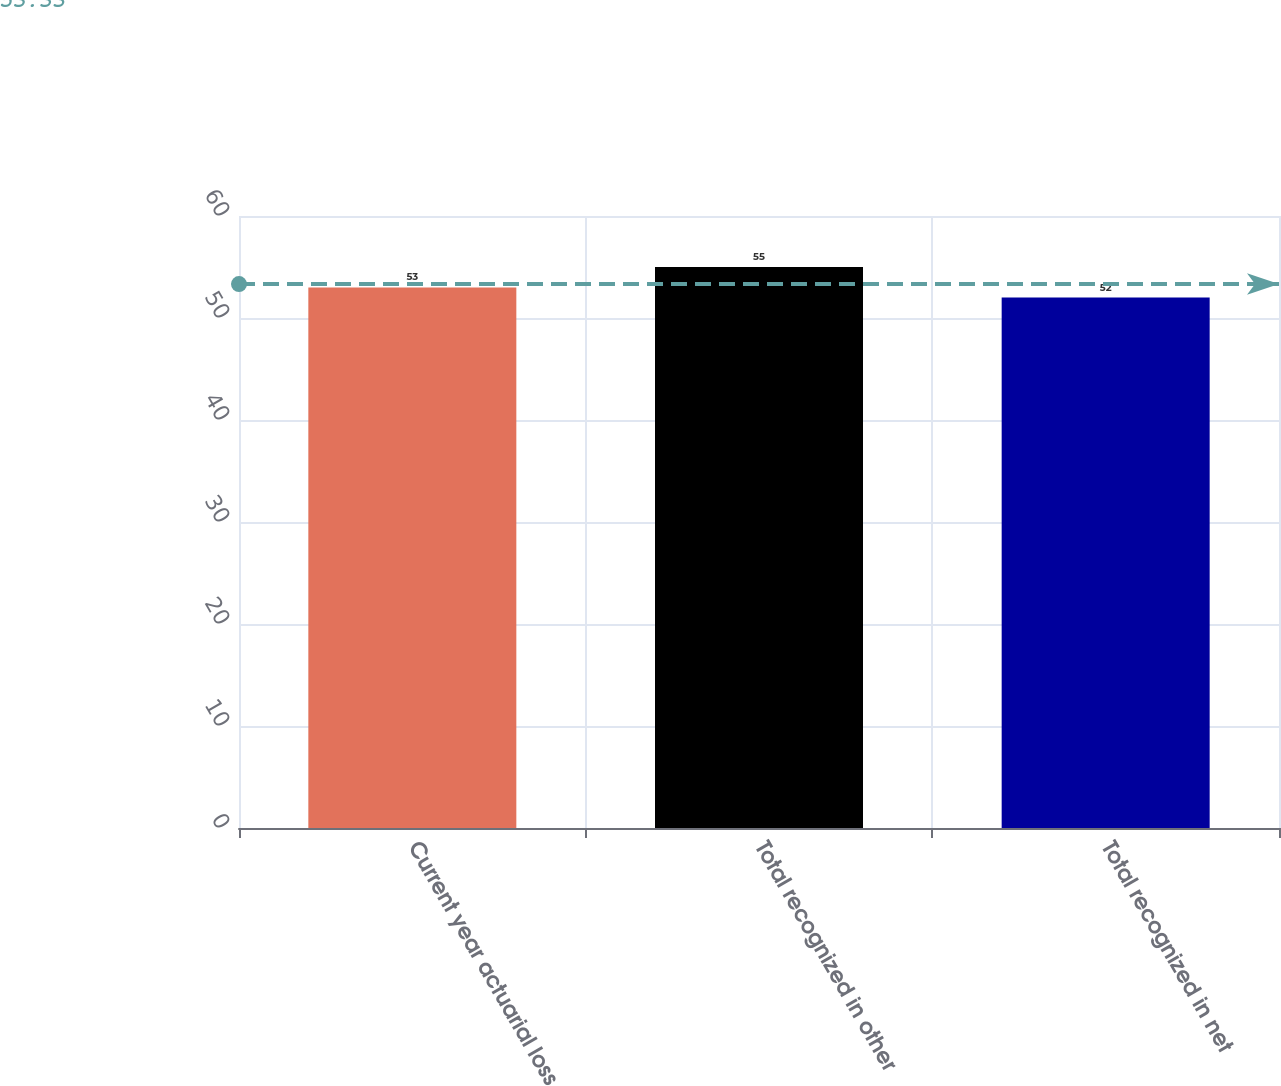Convert chart. <chart><loc_0><loc_0><loc_500><loc_500><bar_chart><fcel>Current year actuarial loss<fcel>Total recognized in other<fcel>Total recognized in net<nl><fcel>53<fcel>55<fcel>52<nl></chart> 